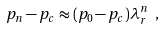Convert formula to latex. <formula><loc_0><loc_0><loc_500><loc_500>p _ { n } - p _ { c } \approx ( p _ { 0 } - p _ { c } ) \lambda _ { r } ^ { n } \ ,</formula> 